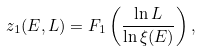<formula> <loc_0><loc_0><loc_500><loc_500>z _ { 1 } ( E , L ) = F _ { 1 } \left ( \frac { \ln L } { \ln \xi ( E ) } \right ) ,</formula> 